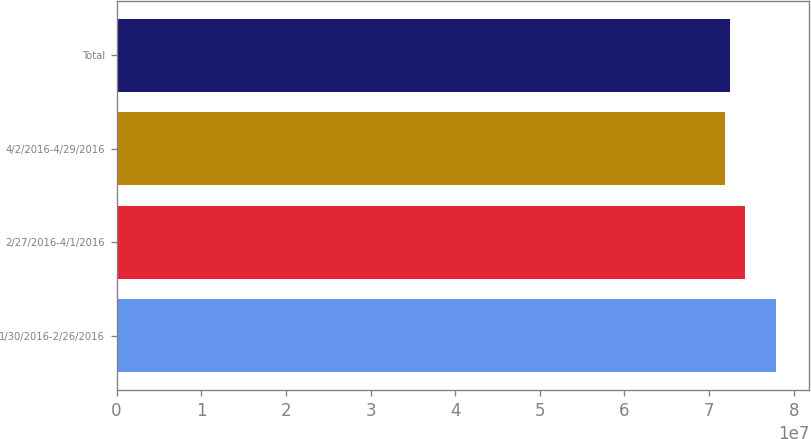<chart> <loc_0><loc_0><loc_500><loc_500><bar_chart><fcel>1/30/2016-2/26/2016<fcel>2/27/2016-4/1/2016<fcel>4/2/2016-4/29/2016<fcel>Total<nl><fcel>7.79399e+07<fcel>7.42297e+07<fcel>7.18787e+07<fcel>7.24849e+07<nl></chart> 